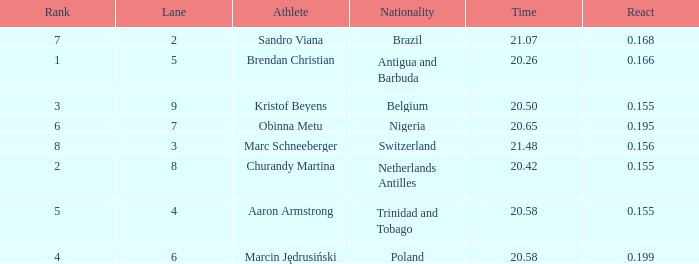Which Lane has a Time larger than 20.5, and a Nationality of trinidad and tobago? 4.0. 